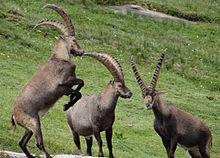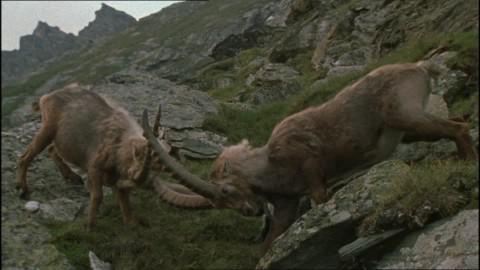The first image is the image on the left, the second image is the image on the right. Examine the images to the left and right. Is the description "All images show at least two horned animals in some kind of face-off, and in one image at least one animal has its front legs off the ground." accurate? Answer yes or no. Yes. The first image is the image on the left, the second image is the image on the right. Examine the images to the left and right. Is the description "There are three antelopes on a rocky mountain in the pair of images." accurate? Answer yes or no. No. 